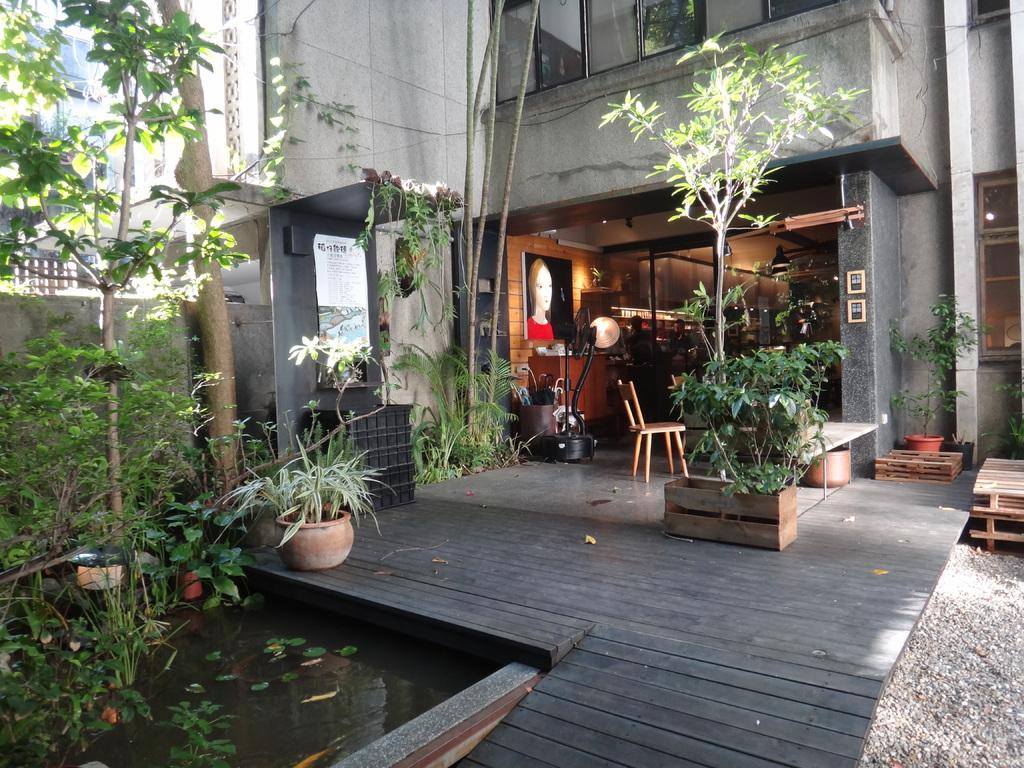What type of living organisms can be seen in the image? Plants, trees, and flowers are visible in the image. What is the primary element visible in the image? Water is visible in the image. What is hanging on the wall in the image? There is a banner and a picture on the wall. What type of structure is present in the image? There is a building in the image. What is the material of the frames on the wall? The frames on the wall are made of wood. How many persons are visible in the image? There are persons visible in the image. What object can be seen on the ground in the image? There is a wooden box in the image. What else can be seen in the image besides the mentioned elements? There are objects in the image. What type of steel is used to make the shoes visible in the image? There are no shoes present in the image, so the type of steel used cannot be determined. What is the temperature like during the summer season depicted in the image? The image does not depict a specific season, so it cannot be determined if it is summer or not. 